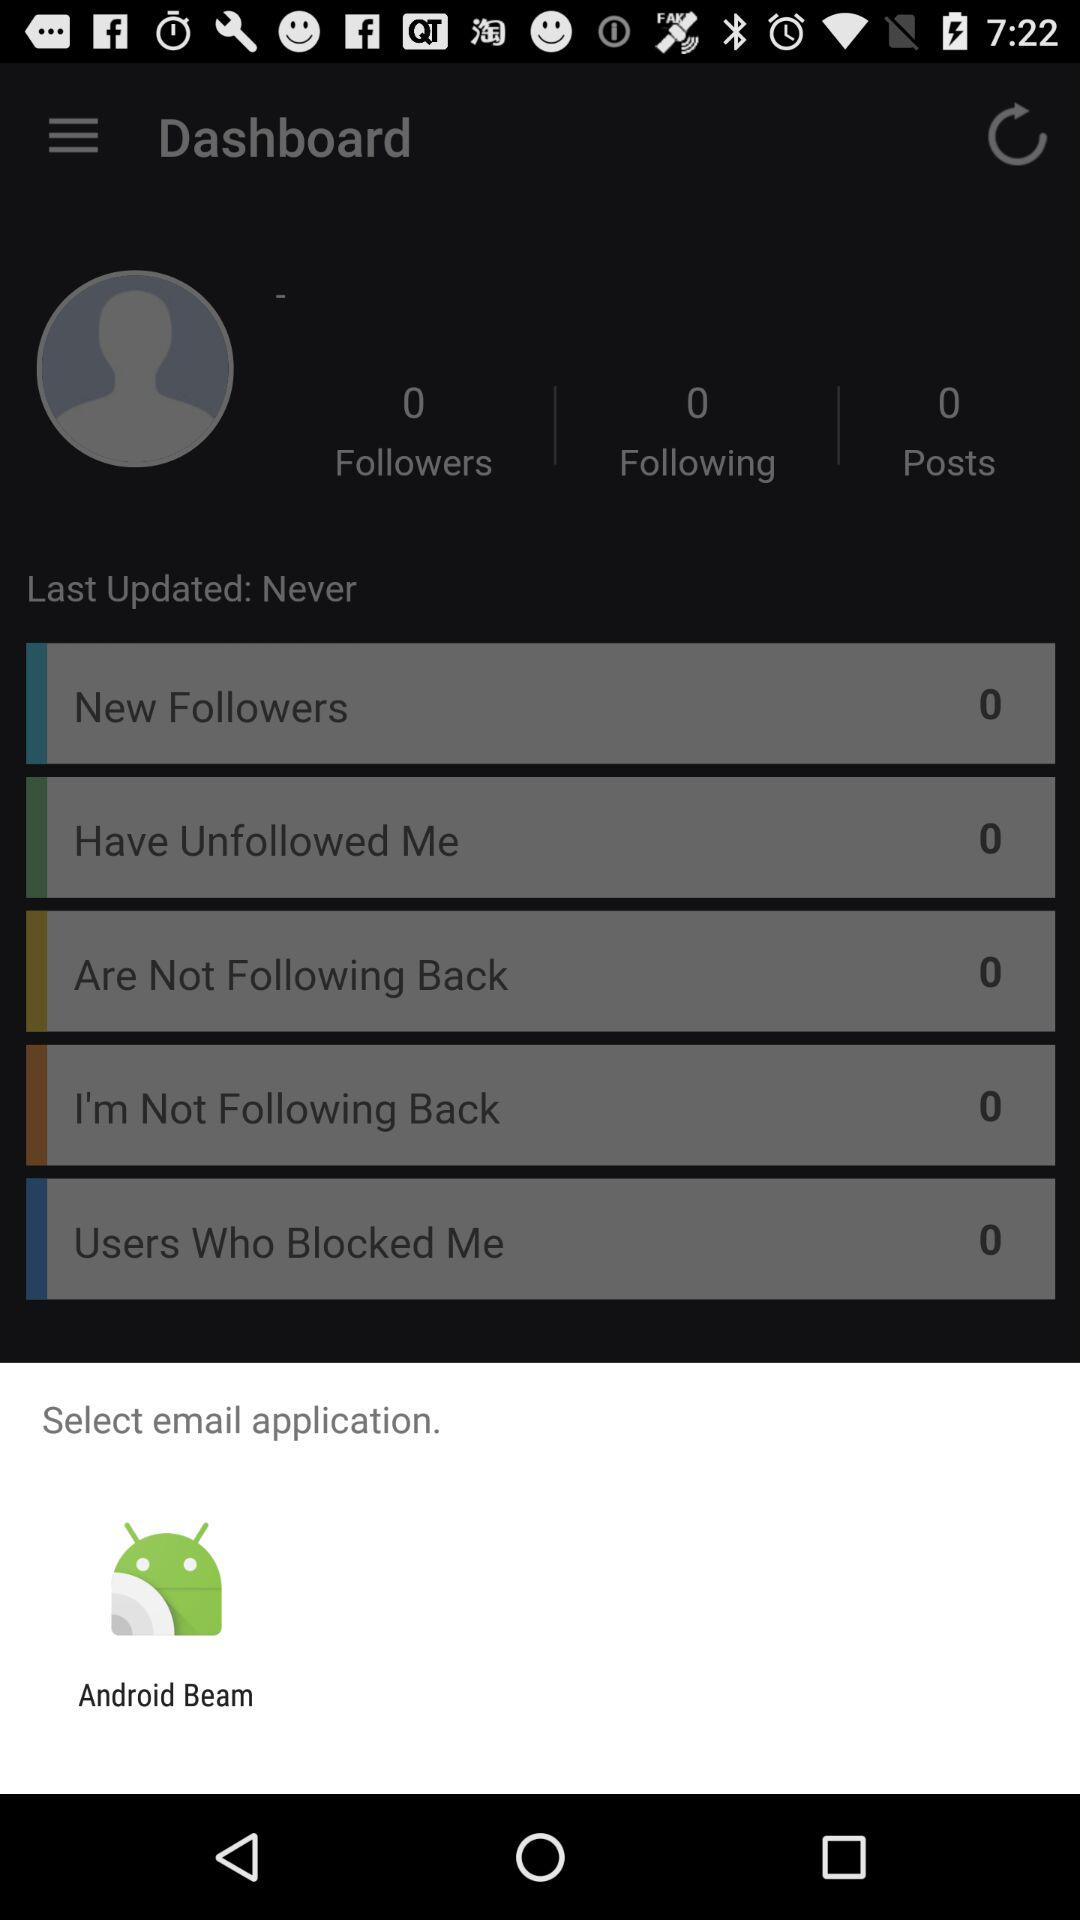How many new followers are there? There are 0 new followers. 